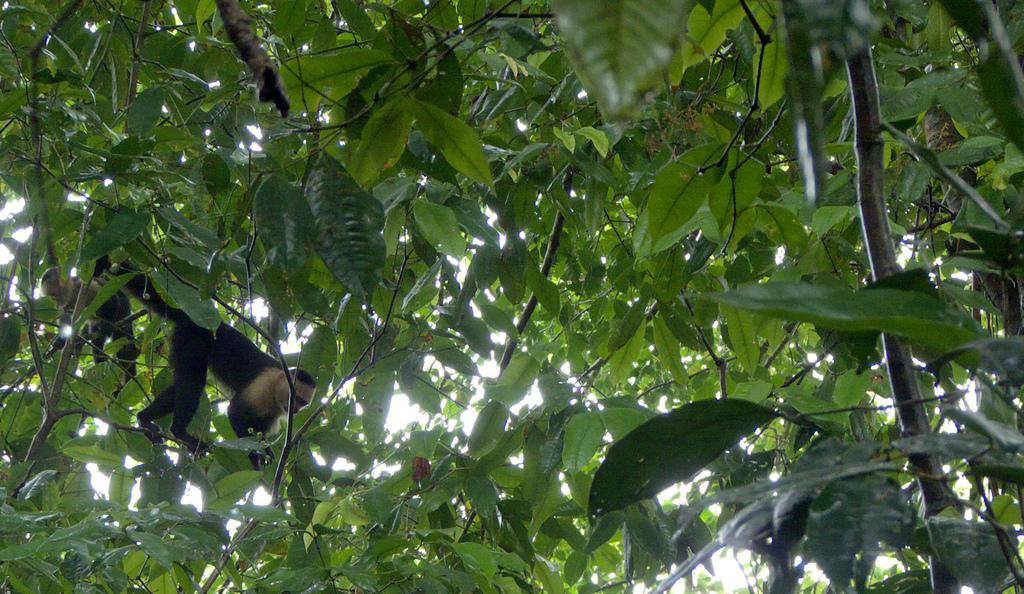Describe this image in one or two sentences. In this picture I can see a monkey on the tree. 